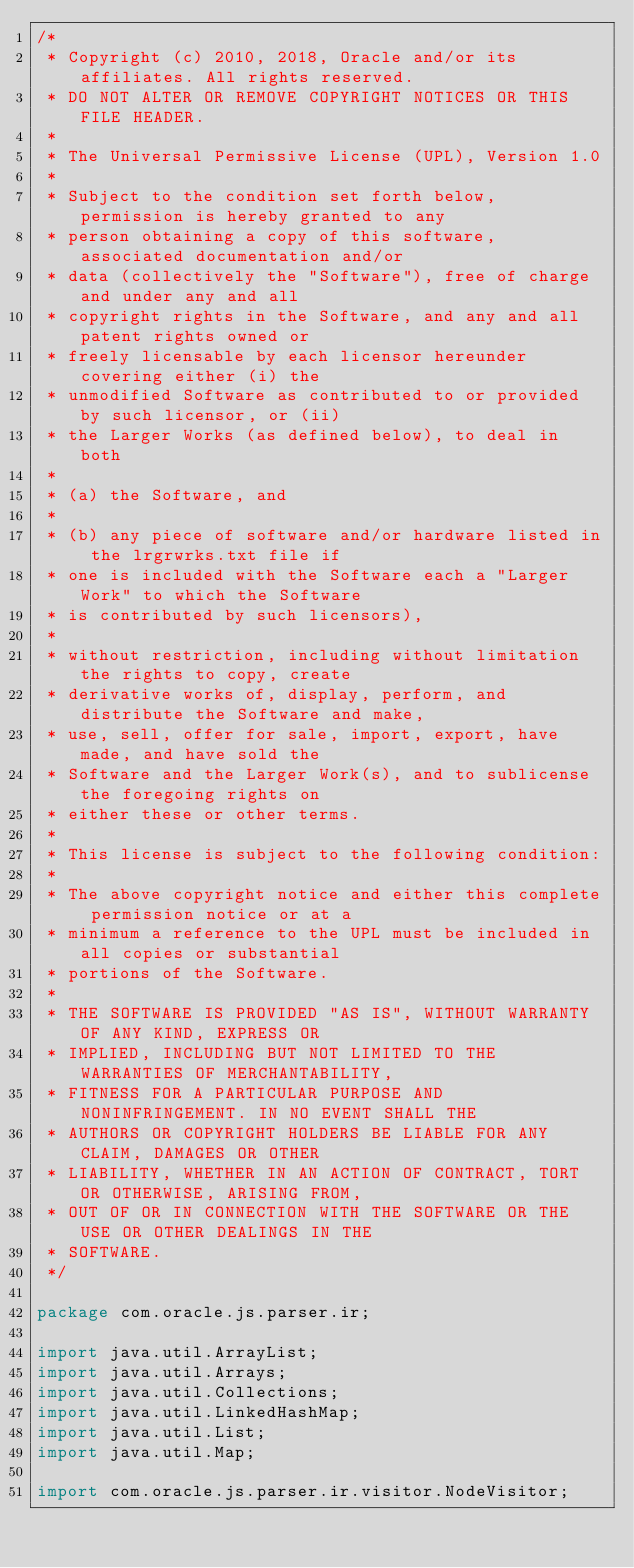Convert code to text. <code><loc_0><loc_0><loc_500><loc_500><_Java_>/*
 * Copyright (c) 2010, 2018, Oracle and/or its affiliates. All rights reserved.
 * DO NOT ALTER OR REMOVE COPYRIGHT NOTICES OR THIS FILE HEADER.
 *
 * The Universal Permissive License (UPL), Version 1.0
 *
 * Subject to the condition set forth below, permission is hereby granted to any
 * person obtaining a copy of this software, associated documentation and/or
 * data (collectively the "Software"), free of charge and under any and all
 * copyright rights in the Software, and any and all patent rights owned or
 * freely licensable by each licensor hereunder covering either (i) the
 * unmodified Software as contributed to or provided by such licensor, or (ii)
 * the Larger Works (as defined below), to deal in both
 *
 * (a) the Software, and
 *
 * (b) any piece of software and/or hardware listed in the lrgrwrks.txt file if
 * one is included with the Software each a "Larger Work" to which the Software
 * is contributed by such licensors),
 *
 * without restriction, including without limitation the rights to copy, create
 * derivative works of, display, perform, and distribute the Software and make,
 * use, sell, offer for sale, import, export, have made, and have sold the
 * Software and the Larger Work(s), and to sublicense the foregoing rights on
 * either these or other terms.
 *
 * This license is subject to the following condition:
 *
 * The above copyright notice and either this complete permission notice or at a
 * minimum a reference to the UPL must be included in all copies or substantial
 * portions of the Software.
 *
 * THE SOFTWARE IS PROVIDED "AS IS", WITHOUT WARRANTY OF ANY KIND, EXPRESS OR
 * IMPLIED, INCLUDING BUT NOT LIMITED TO THE WARRANTIES OF MERCHANTABILITY,
 * FITNESS FOR A PARTICULAR PURPOSE AND NONINFRINGEMENT. IN NO EVENT SHALL THE
 * AUTHORS OR COPYRIGHT HOLDERS BE LIABLE FOR ANY CLAIM, DAMAGES OR OTHER
 * LIABILITY, WHETHER IN AN ACTION OF CONTRACT, TORT OR OTHERWISE, ARISING FROM,
 * OUT OF OR IN CONNECTION WITH THE SOFTWARE OR THE USE OR OTHER DEALINGS IN THE
 * SOFTWARE.
 */

package com.oracle.js.parser.ir;

import java.util.ArrayList;
import java.util.Arrays;
import java.util.Collections;
import java.util.LinkedHashMap;
import java.util.List;
import java.util.Map;

import com.oracle.js.parser.ir.visitor.NodeVisitor;</code> 